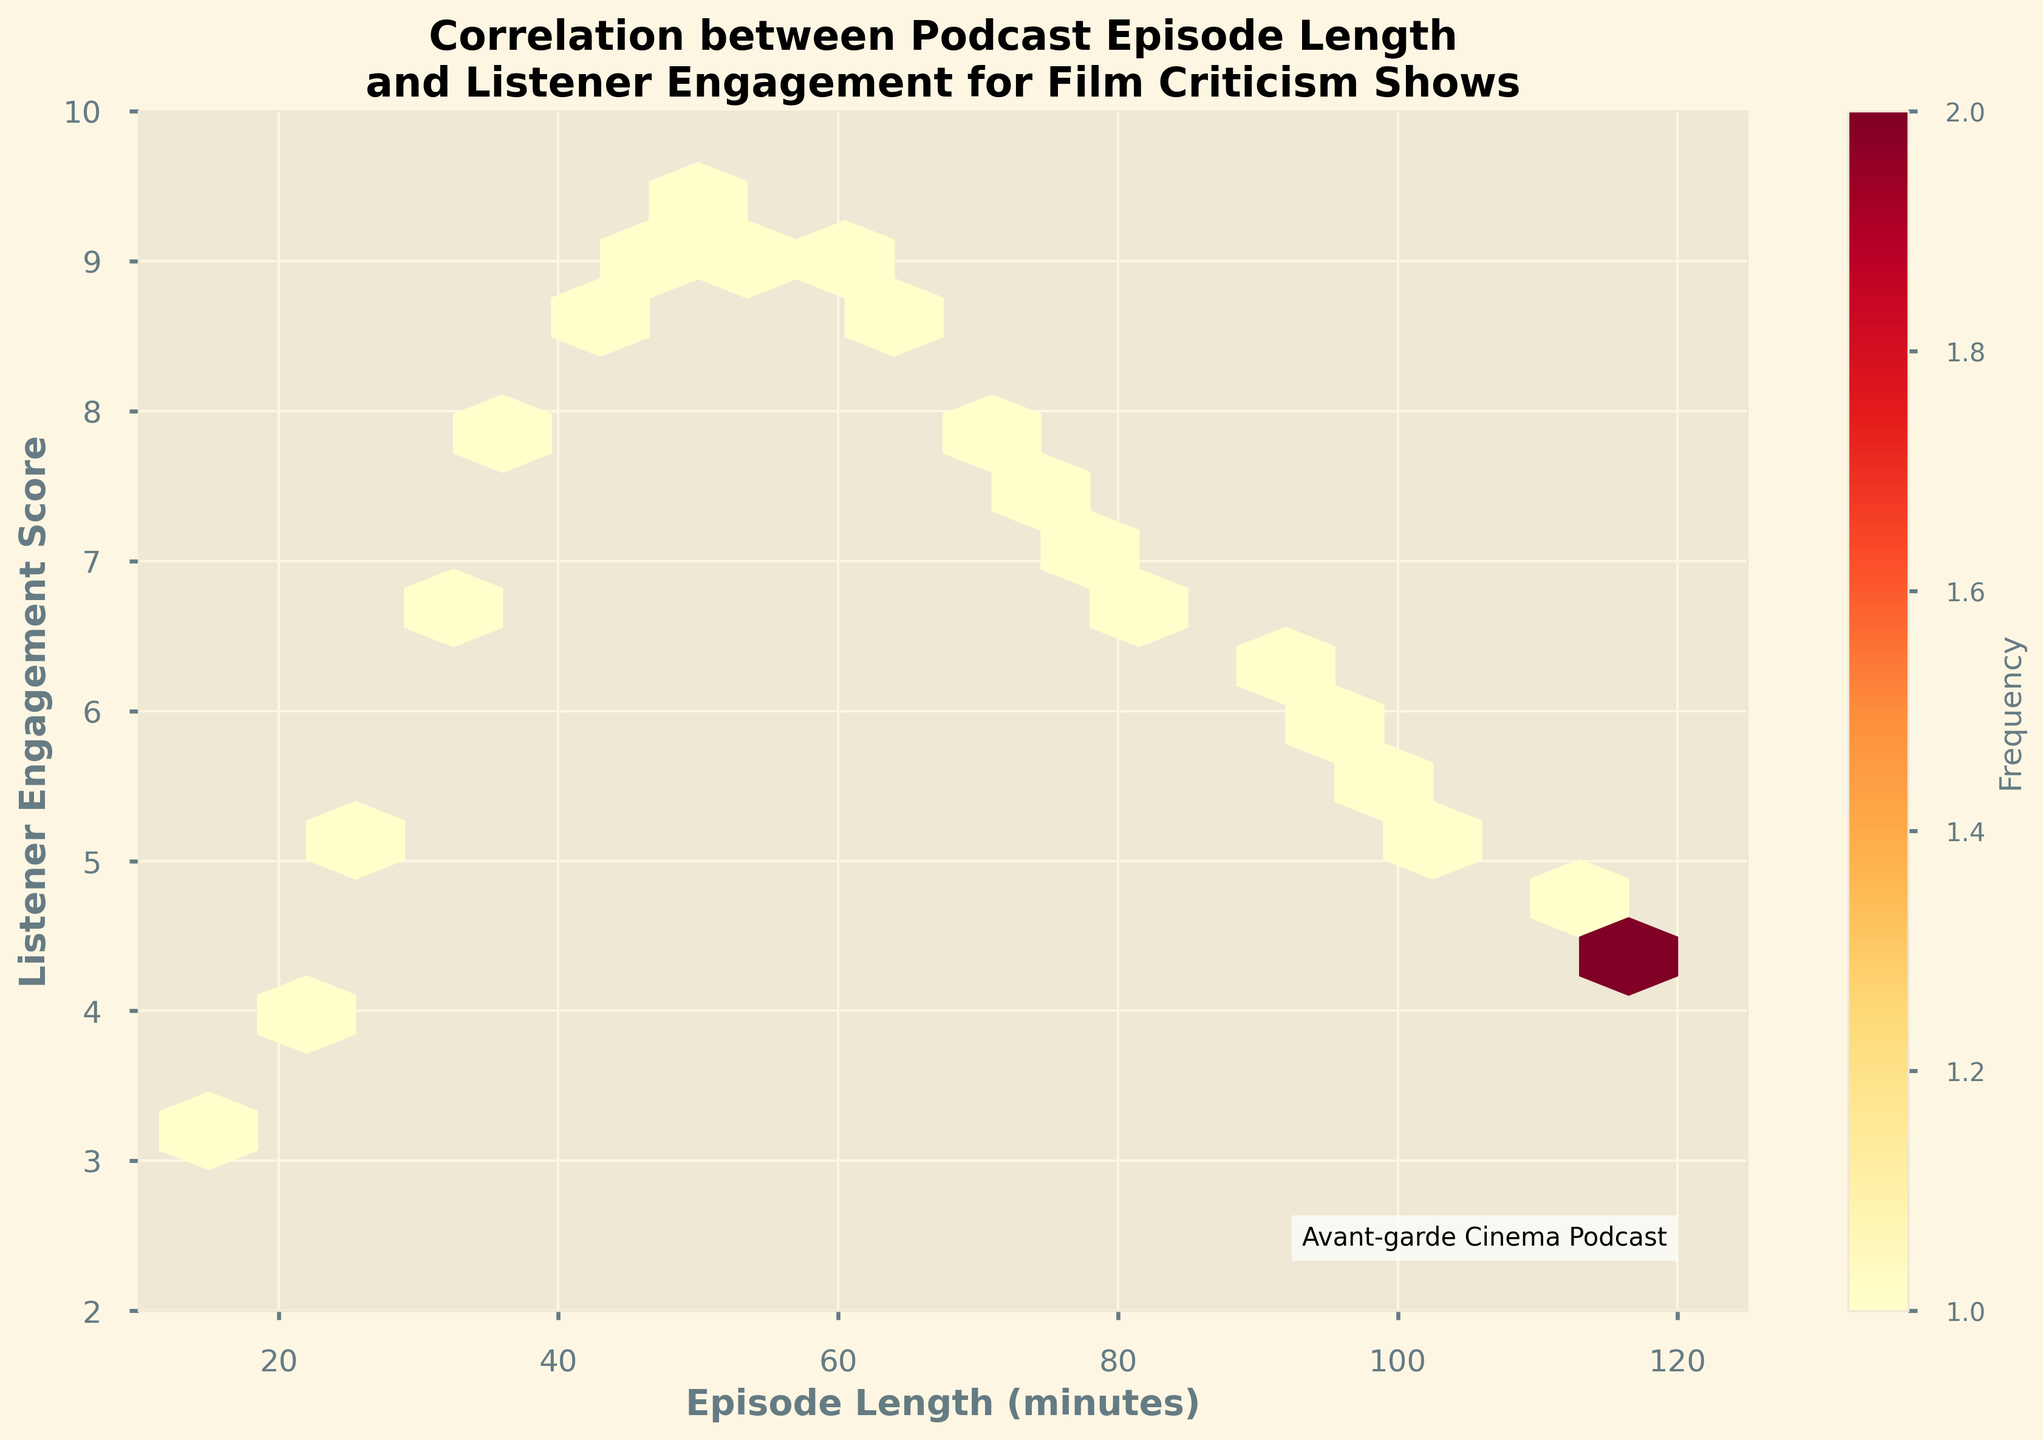What is the title of the Hexbin plot? The title is displayed prominently at the top of the plot.
Answer: Correlation between Podcast Episode Length and Listener Engagement for Film Criticism Shows What are the labels for the x-axis and y-axis? The x-axis and y-axis labels are mentioned alongside their respective axes.
Answer: Episode Length (minutes), Listener Engagement Score Within what range does the x-axis display values? The x-axis range can be seen by observing its limits at the bottom of the plot.
Answer: 10 to 125 What is the range of the y-axis? The y-axis range can be determined by checking its limits on the left side of the plot.
Answer: 2 to 10 What color indicates the highest frequency in the plot? The color indicating the highest frequency can be seen in the color bar's top end, generally darker or more intense.
Answer: Dark Red Which episode length seems to have the highest listener engagement score based on the hexbin plot? By observing the hexbin plot, identify where the densest hexagons cluster around the highest engagement scores.
Answer: 50 minutes At around what episode length does listener engagement start to decrease significantly? Look for the point where the color density begins to diminish moving to the right past the peak.
Answer: After 55 minutes Compare the listener engagement score at 30 minutes and 90 minutes. Observe the engagement score on the y-axis for both 30 and 90 minutes episode lengths and compare them.
Answer: Higher at 30 minutes What visual feature indicates the frequency of data points in the plot? The plot uses hexagons, and the color intensity within these hexagons shows the frequency of data points.
Answer: Color intensity of hexagons What technique is used in this plot for binning the data points? The technique for visualizing density in this plot uses hexagons, evident from the hexagonal shapes used throughout the plot.
Answer: Hexagonal binning (hexbin) 